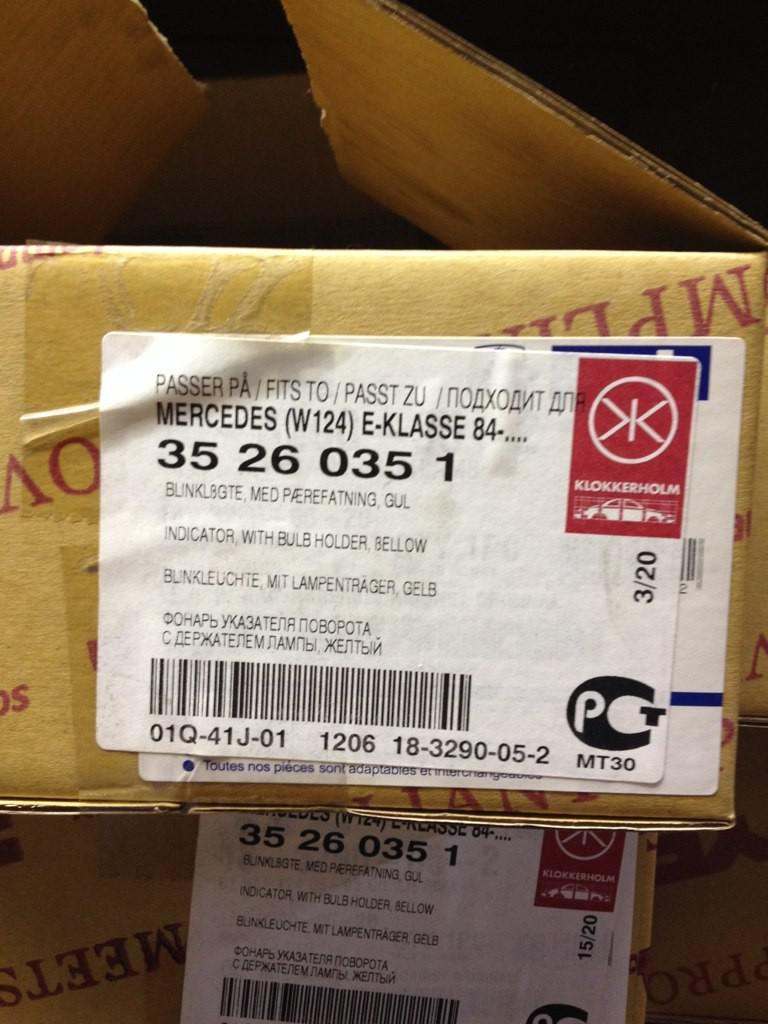What could be inside that box?
Give a very brief answer. Unanswerable. What luxury car name is on this box?
Provide a short and direct response. Mercedes. 